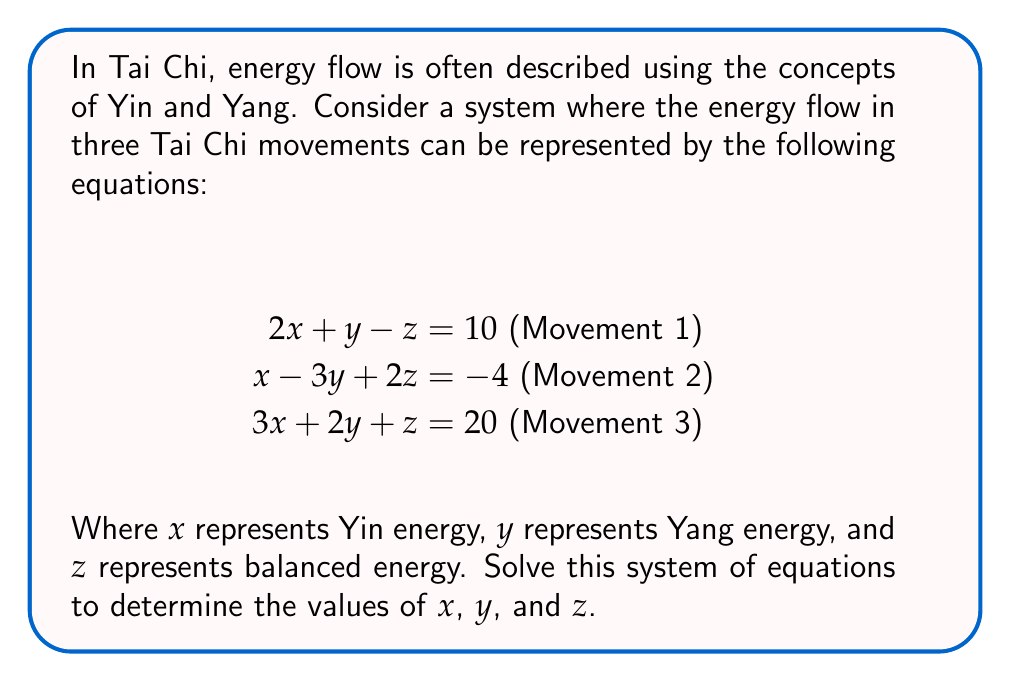Solve this math problem. To solve this system of linear equations, we'll use the elimination method:

Step 1: Eliminate $z$ by adding equations (1) and (2):
$$(2x + y - z) + (x - 3y + 2z) = 10 + (-4)$$
$$3x - 2y + z = 6 \text{ (Equation 4)}$$

Step 2: Eliminate $z$ by subtracting equation (3) from equation (4):
$$(3x - 2y + z) - (3x + 2y + z) = 6 - 20$$
$$-4y = -14$$
$$y = \frac{14}{4} = 3.5$$

Step 3: Substitute $y = 3.5$ into equation (1):
$$2x + 3.5 - z = 10$$
$$2x - z = 6.5 \text{ (Equation 5)}$$

Step 4: Substitute $y = 3.5$ into equation (2):
$$x - 3(3.5) + 2z = -4$$
$$x - 10.5 + 2z = -4$$
$$x + 2z = 6.5 \text{ (Equation 6)}$$

Step 5: Subtract equation (5) from equation (6):
$$(x + 2z) - (2x - z) = 6.5 - 6.5$$
$$-x + 3z = 0$$
$$x = 3z$$

Step 6: Substitute $x = 3z$ into equation (5):
$$2(3z) - z = 6.5$$
$$6z - z = 6.5$$
$$5z = 6.5$$
$$z = 1.3$$

Step 7: Calculate $x$ by substituting $z = 1.3$ into $x = 3z$:
$$x = 3(1.3) = 3.9$$

Therefore, we have:
$x = 3.9$ (Yin energy)
$y = 3.5$ (Yang energy)
$z = 1.3$ (Balanced energy)
Answer: $x = 3.9, y = 3.5, z = 1.3$ 